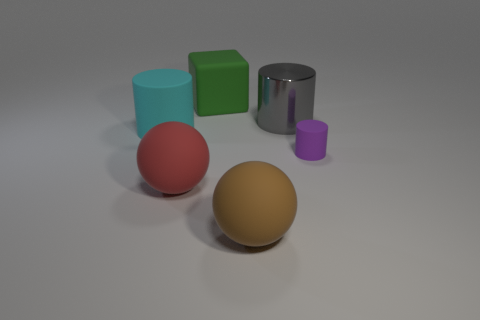Is there anything else that is the same material as the large gray object?
Offer a terse response. No. There is a rubber cylinder that is to the left of the tiny purple matte cylinder; what color is it?
Give a very brief answer. Cyan. Are there any cyan things that have the same size as the matte cube?
Give a very brief answer. Yes. There is a gray cylinder that is the same size as the green cube; what material is it?
Offer a terse response. Metal. How many objects are objects that are behind the cyan cylinder or rubber things that are in front of the metallic cylinder?
Offer a very short reply. 6. Is there a green matte object that has the same shape as the gray metallic object?
Your answer should be compact. No. How many matte objects are large red cylinders or tiny objects?
Provide a succinct answer. 1. What shape is the cyan object?
Offer a terse response. Cylinder. What number of cyan cylinders are the same material as the large red object?
Provide a short and direct response. 1. There is a big cylinder that is the same material as the green block; what is its color?
Make the answer very short. Cyan. 